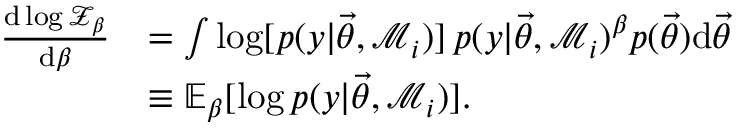Convert formula to latex. <formula><loc_0><loc_0><loc_500><loc_500>\begin{array} { r l } { \frac { d \log \mathcal { Z } _ { \beta } } { d \beta } } & { = \int \log [ p ( y | { \vec { \theta } } , \mathcal { M } _ { i } ) ] \, p ( y | { \vec { \theta } } , \mathcal { M } _ { i } ) ^ { \beta } p ( { \vec { \theta } } ) d { \vec { \theta } } } \\ & { \equiv \mathbb { E } _ { \beta } [ \log p ( y | { \vec { \theta } } , \mathcal { M } _ { i } ) ] . } \end{array}</formula> 